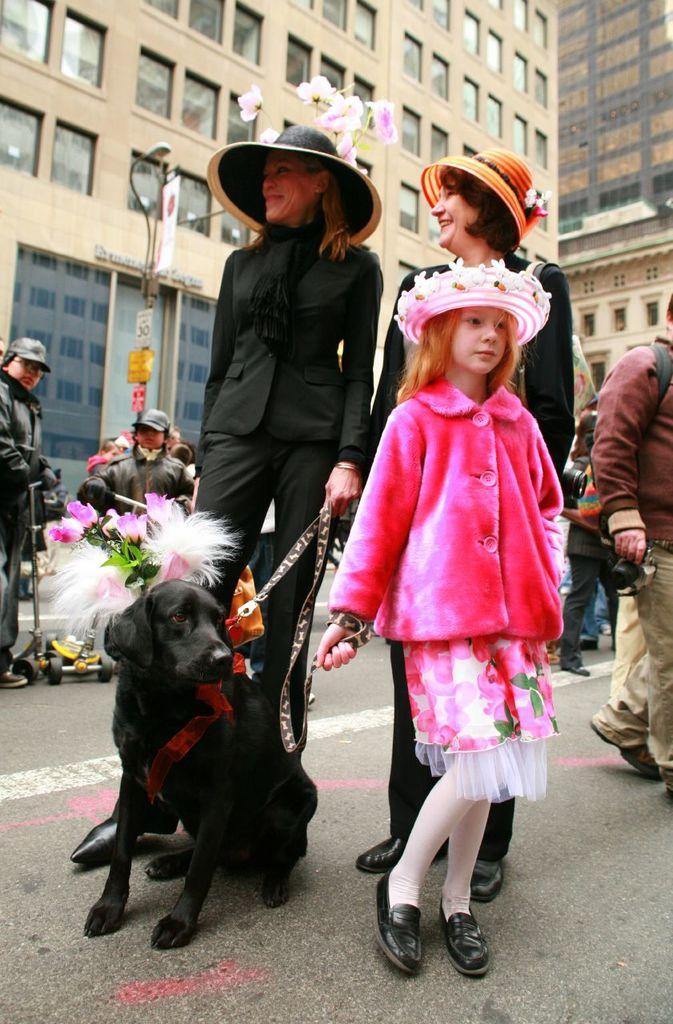How many people are present in the image? There are two women and a girl in the image, making a total of three people. What is the setting of the image? They are standing on a road. What other living creature is present in the image? There is a dog in the image. Are there any other individuals in the vicinity of the three people? Yes, there are people surrounding them. What type of cave can be seen in the background of the image? There is no cave present in the image; it features a road with people and a dog. What game are the people playing in the image? There is no game, such as chess, being played in the image. 